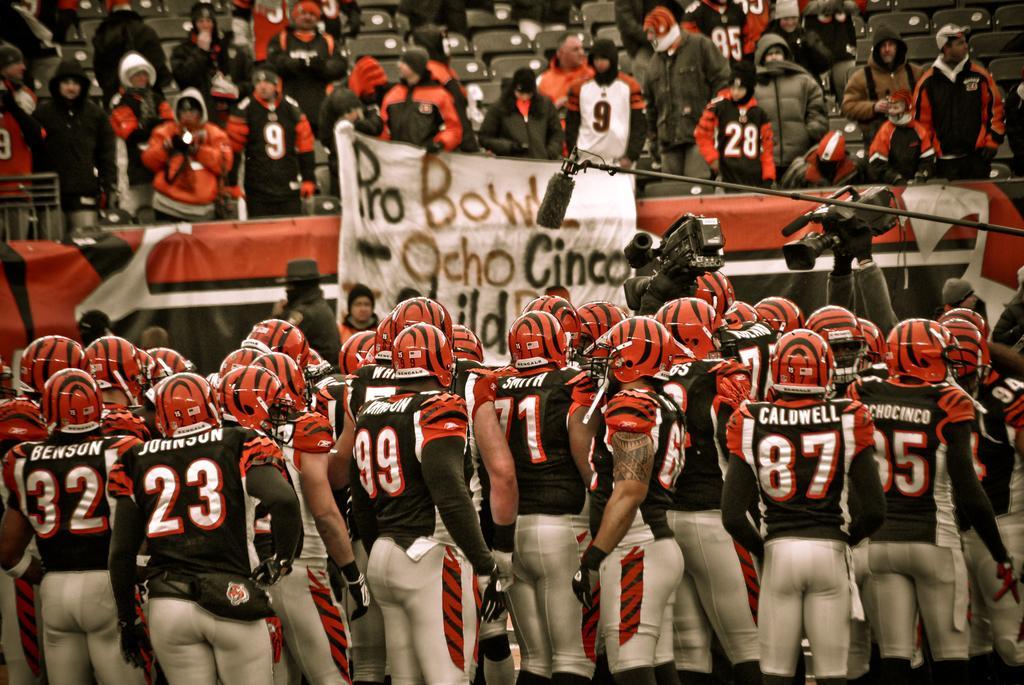Could you give a brief overview of what you see in this image? Here we can see people, cameras and mic. These people wore helmets. Background we can see people, chairs and hoardings. On this person hand there is tattoo. 